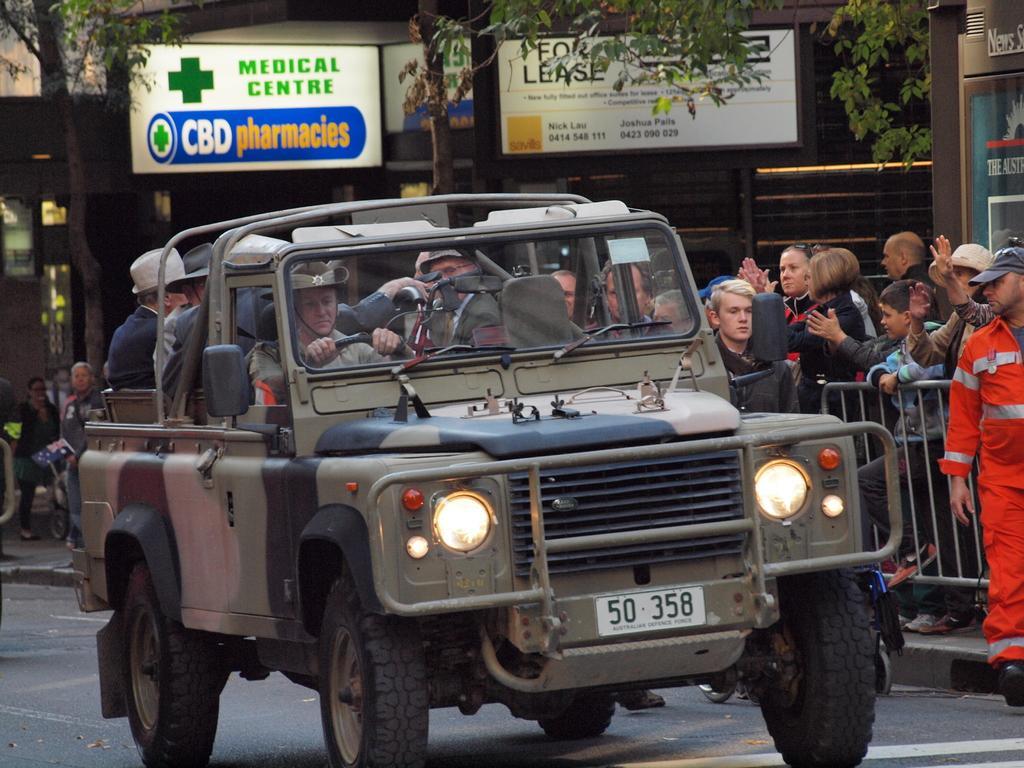How would you summarize this image in a sentence or two? This picture is clicked outside. In the center we can see the group of persons sitting in the jeep and a person riding a jeep. On the right we can see the group of people standing on the ground and we can see the metal rods. In the background we can see the trees, buildings, boards on which we can see the text and some other items. 